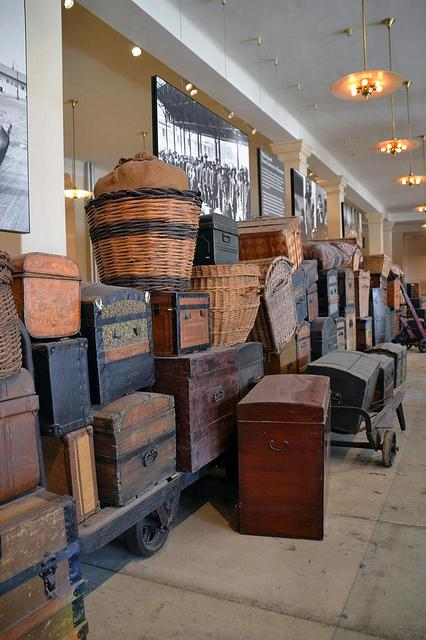What are the largest rectangular clothing item storage pieces called?

Choices:
A) suitcases
B) valises
C) baskets
D) trunks trunks 